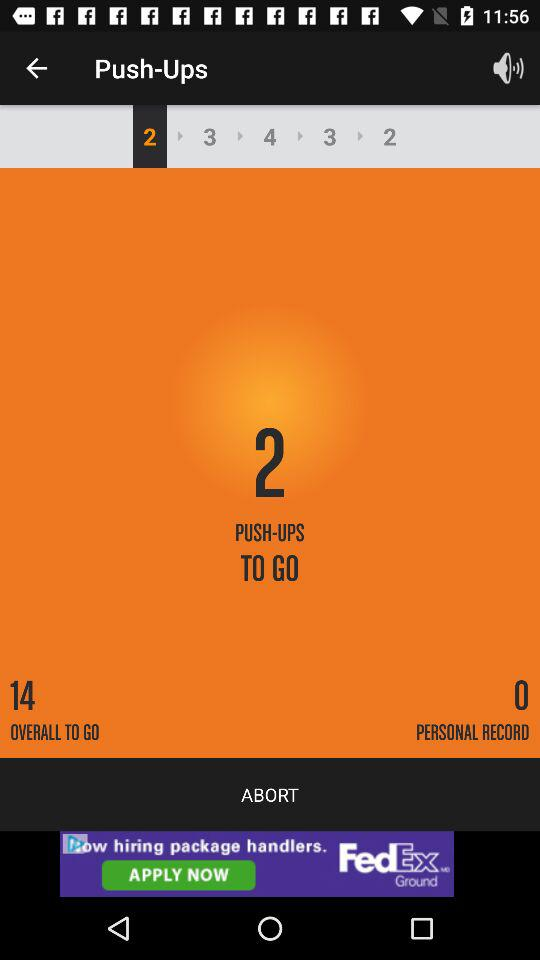How many overall push-ups are left? There are 14 push-ups left. 